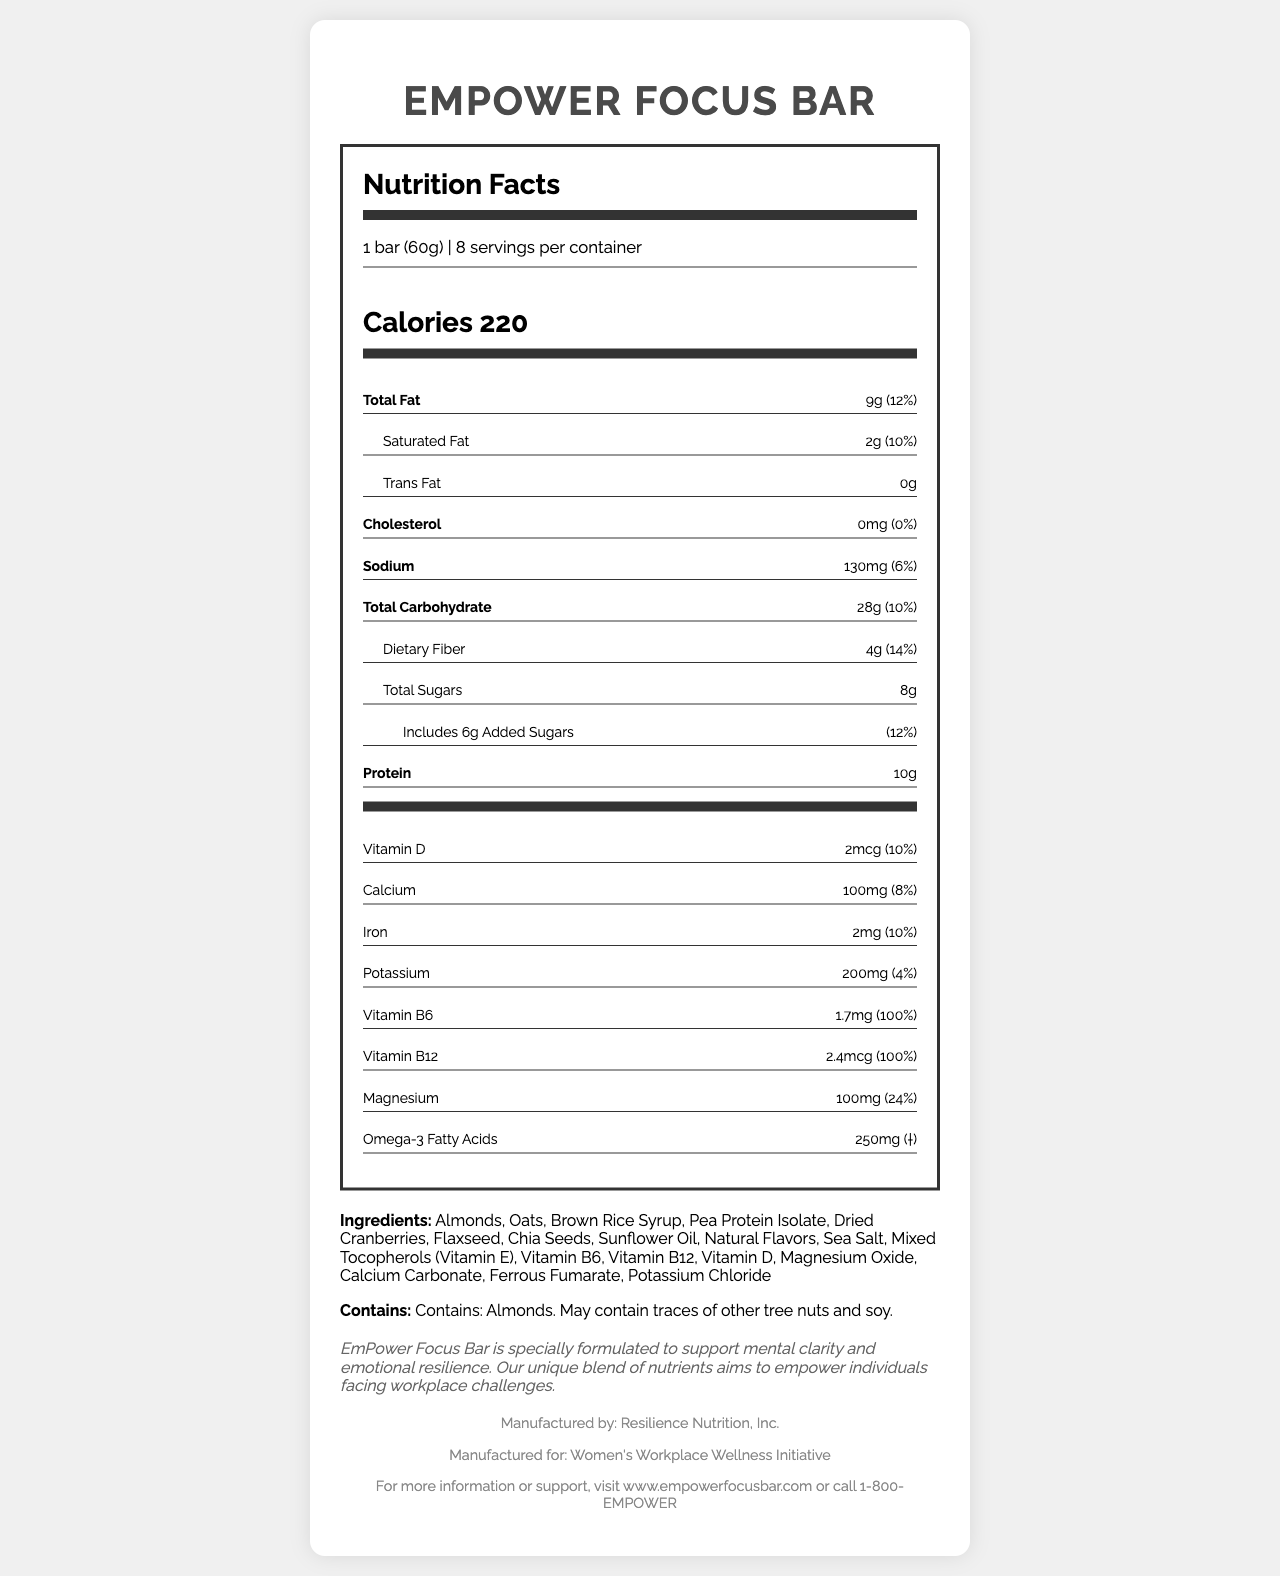what is the serving size of the EmPower Focus Bar? The serving size is explicitly mentioned in the nutrition label as "1 bar (60g)".
Answer: 1 bar (60g) how many calories are there per serving? The calories per serving are listed as "220" in the nutrition facts section.
Answer: 220 what is the total fat content per serving? The total fat content per serving is indicated as "9g" in the nutrition information.
Answer: 9g how much dietary fiber does the EmPower Focus Bar contain? The dietary fiber content is specified as "4g" in the nutrition facts.
Answer: 4g what is the percent daily value of Vitamin B6 in the EmPower Focus Bar? The nutrition label states that the percent daily value of Vitamin B6 is "100%".
Answer: 100% does the EmPower Focus Bar contain any trans fat? The nutrition label lists "Trans Fat 0g", indicating there is no trans fat.
Answer: No what specific ingredient might cause allergies? The allergen statement specifies "Contains: Almonds."
Answer: Almonds which vitamins have a 100% Daily Value in one serving of the EmPower Focus Bar? A. Vitamin B6 and Vitamin B12 B. Vitamin D and Calcium C. Vitamin A and Vitamin C The nutrition label indicates that both Vitamin B6 and Vitamin B12 have a 100% Daily Value.
Answer: A how much protein does each serving of the EmPower Focus Bar provide? The protein content per serving is listed as "10g".
Answer: 10g what are the main claims highlighted by the EmPower Focus Bar? The claim statements section lists these attributes.
Answer: Good source of fiber, excellent source of Vitamin B6 and B12, contains Omega-3 fatty acids, no artificial colors, flavors, or preservatives which of the following is NOT an ingredient in the EmPower Focus Bar? I. Almonds II. Pea Protein Isolate III. Glucose Syrup The ingredients list includes Almonds and Pea Protein Isolate but does not mention Glucose Syrup.
Answer: III. Glucose Syrup is the EmPower Focus Bar a good source of fiber? One of the claim statements clearly says "Good source of fiber".
Answer: Yes summarize the EmPower Focus Bar document. This summary captures the main nutritional facts, key ingredients, and the brand's purpose statement.
Answer: The EmPower Focus Bar is an energy bar that supports mental health and focus, with 220 calories per serving and key nutrients like Vitamin B6, B12, and Omega-3. It contains 10g of protein and 4g of dietary fiber per serving and avoids artificial additives. It is produced by Resilience Nutrition, Inc. for the Women’s Workplace Wellness Initiative. how does the EmPower Focus Bar intend to support its users? The brand statement specifies that the bar is designed to support mental clarity and emotional resilience.
Answer: Supports mental clarity and emotional resilience who manufactures the EmPower Focus Bar? The contact information section states the bar is manufactured by Resilience Nutrition, Inc.
Answer: Resilience Nutrition, Inc. is there any information about the flavor of the EmPower Focus Bar? The document lists the presence of natural flavors but does not specify the exact flavor.
Answer: Not enough information 